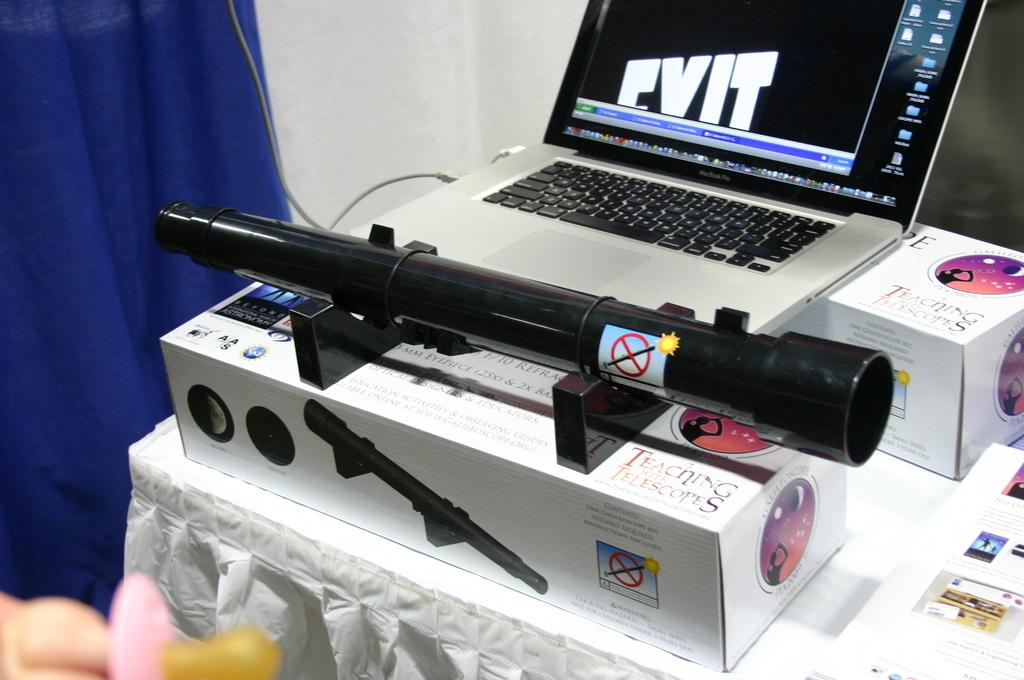<image>
Summarize the visual content of the image. A couple of oblong boxes have Teaching with Telescopes written on them. 